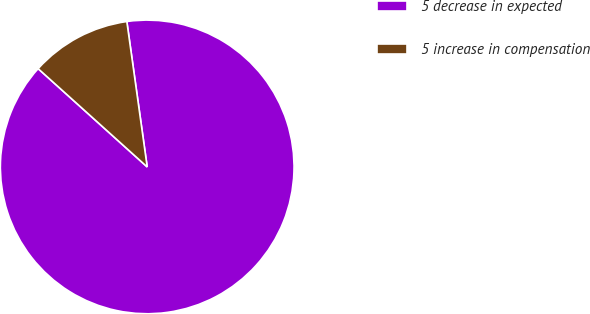<chart> <loc_0><loc_0><loc_500><loc_500><pie_chart><fcel>5 decrease in expected<fcel>5 increase in compensation<nl><fcel>88.89%<fcel>11.11%<nl></chart> 